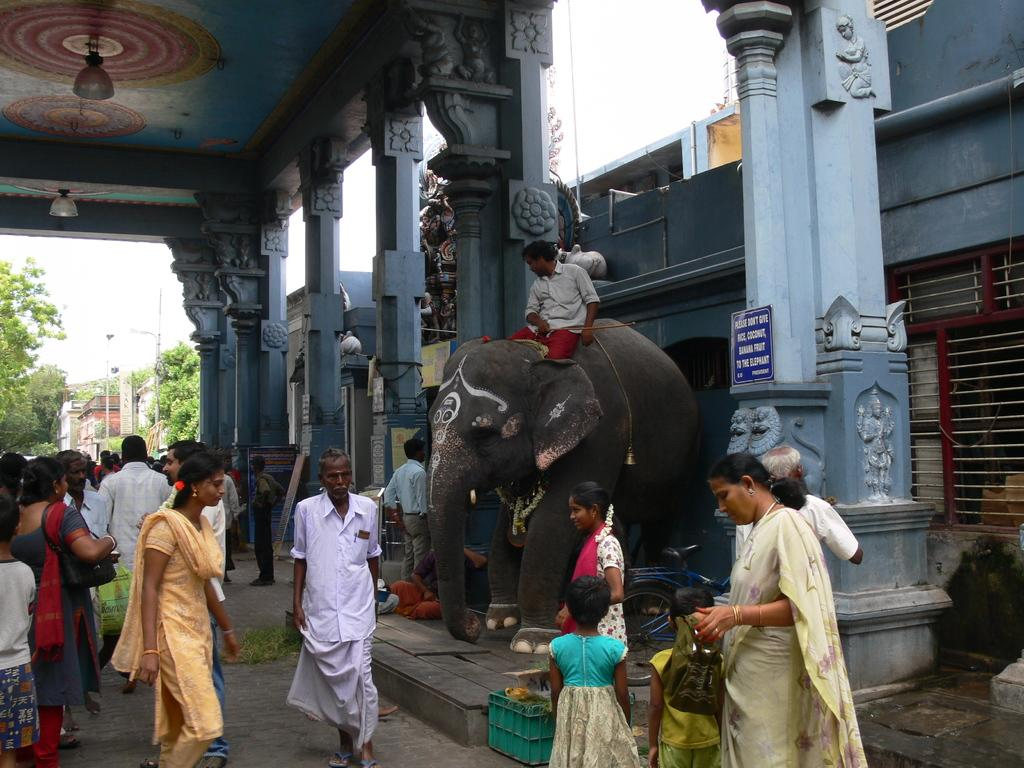What is happening in the image involving the people? There are many people working in the image. What unusual element can be seen in the image? There is an elephant in the image, and a person is sitting on it. What architectural features are present in the image? There are some pillars in the image. What can be seen in the background of the image? There are trees and the sky visible in the background of the image. What type of locket is the achiever wearing in the image? There is no achiever or locket present in the image. Who is the friend of the person sitting on the elephant in the image? There is no friend present in the image; only the person sitting on the elephant and the people working can be seen. 